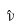Convert formula to latex. <formula><loc_0><loc_0><loc_500><loc_500>\hat { \nu }</formula> 